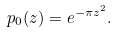<formula> <loc_0><loc_0><loc_500><loc_500>p _ { 0 } ( z ) = e ^ { - \pi z ^ { 2 } } .</formula> 